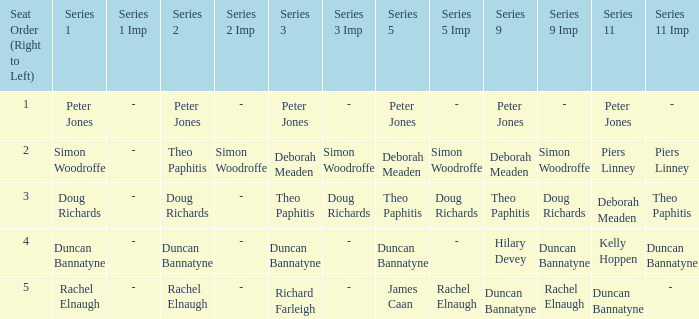Which Series 2 has a Series 3 of deborah meaden? Theo Paphitis. 